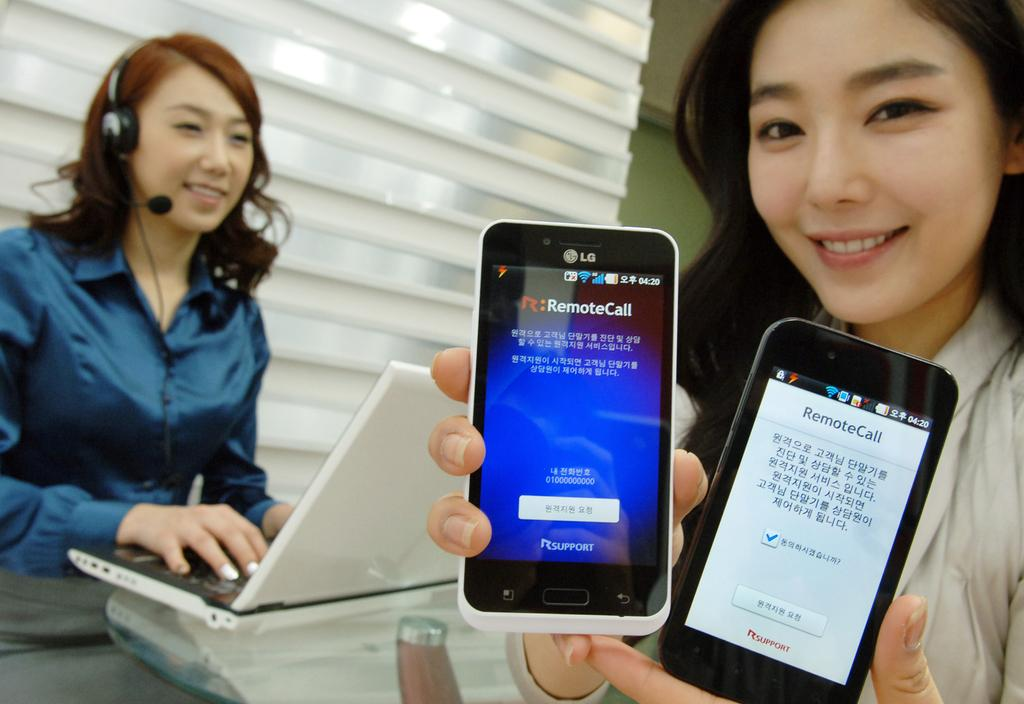<image>
Provide a brief description of the given image. a woman holding two cell phones with remoteCall displayed on the screen 